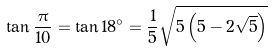<formula> <loc_0><loc_0><loc_500><loc_500>\tan { \frac { \pi } { 1 0 } } = \tan 1 8 ^ { \circ } = { \frac { 1 } { 5 } } { \sqrt { 5 \left ( 5 - 2 { \sqrt { 5 } } \right ) } }</formula> 